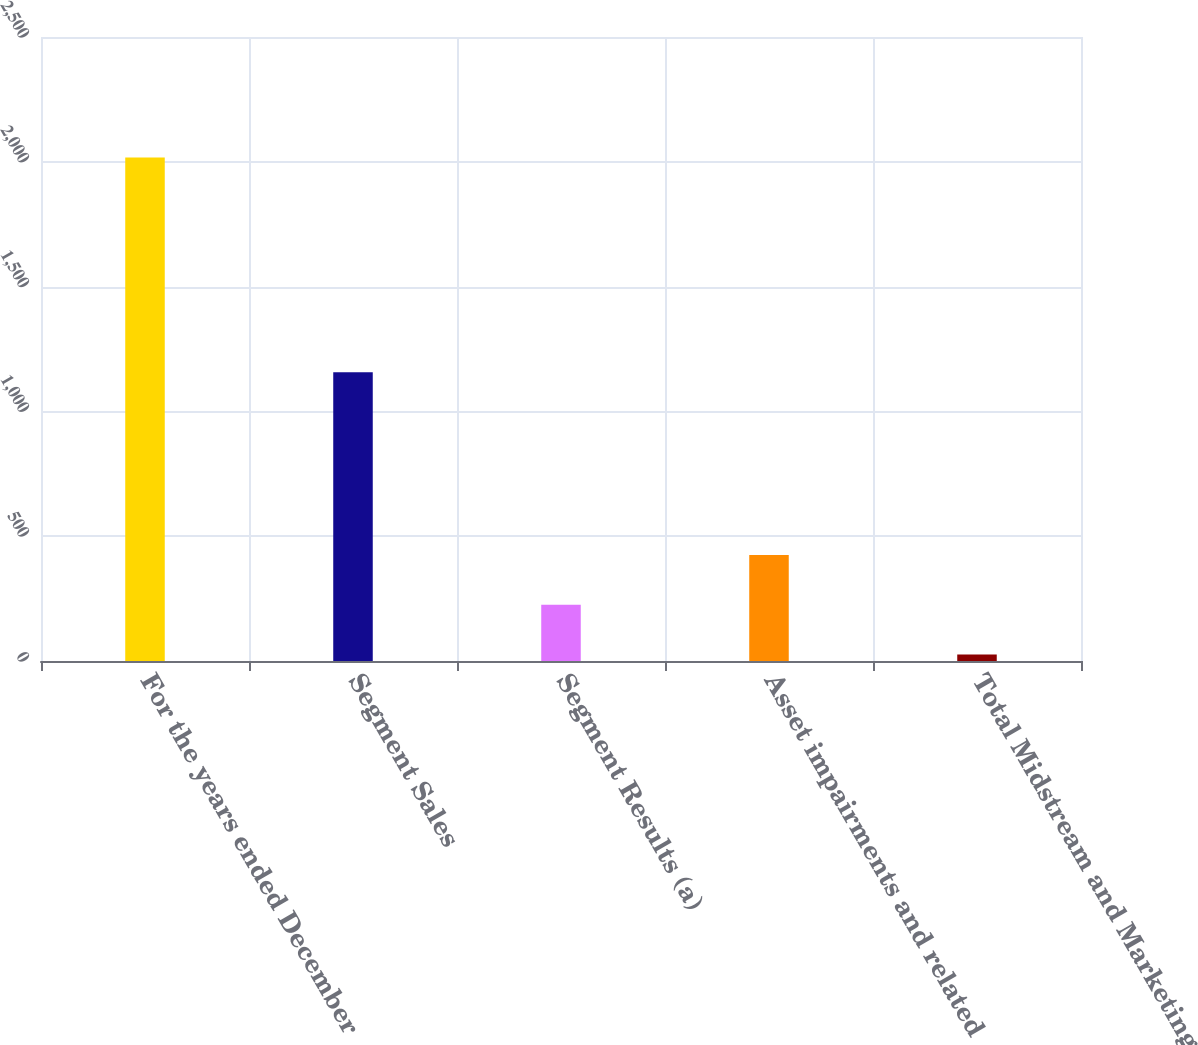Convert chart. <chart><loc_0><loc_0><loc_500><loc_500><bar_chart><fcel>For the years ended December<fcel>Segment Sales<fcel>Segment Results (a)<fcel>Asset impairments and related<fcel>Total Midstream and Marketing<nl><fcel>2017<fcel>1157<fcel>225.1<fcel>424.2<fcel>26<nl></chart> 